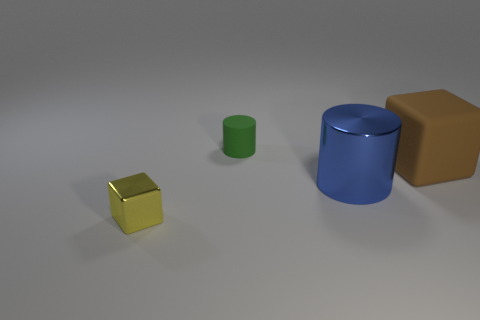Subtract all blue cylinders. Subtract all purple balls. How many cylinders are left? 1 Add 1 brown things. How many objects exist? 5 Add 2 cyan metallic things. How many cyan metallic things exist? 2 Subtract 0 brown cylinders. How many objects are left? 4 Subtract all small green objects. Subtract all big cylinders. How many objects are left? 2 Add 2 big matte objects. How many big matte objects are left? 3 